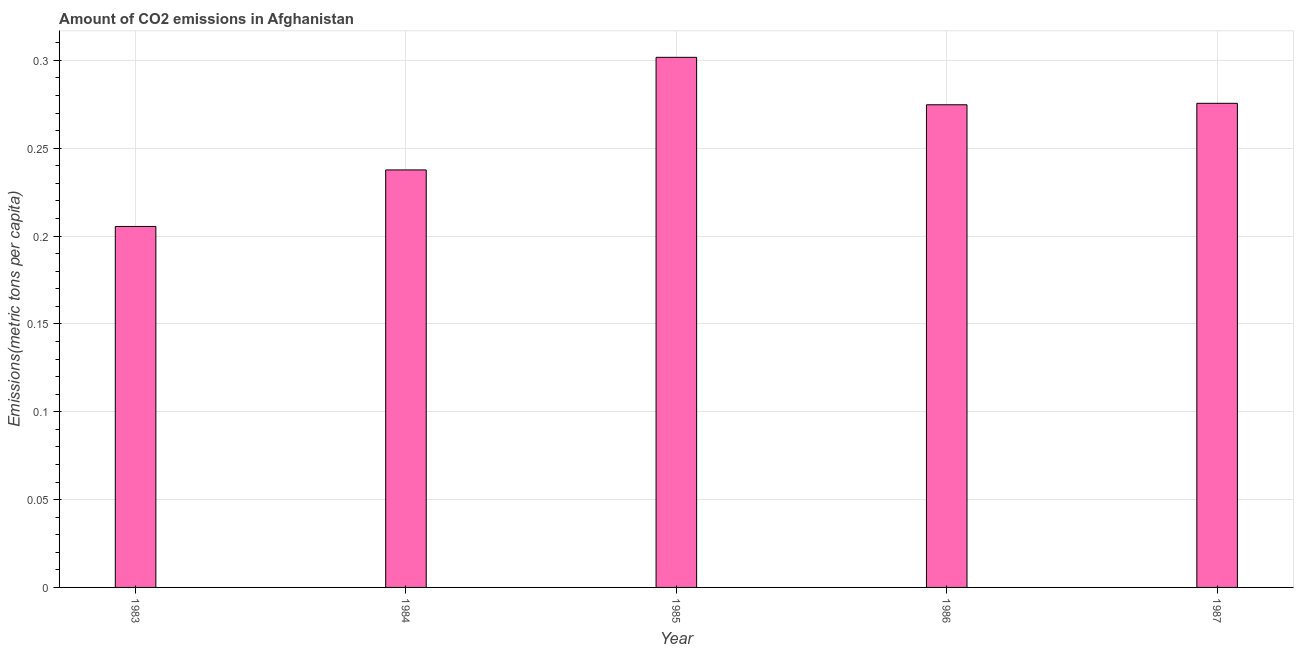Does the graph contain grids?
Give a very brief answer. Yes. What is the title of the graph?
Your answer should be very brief. Amount of CO2 emissions in Afghanistan. What is the label or title of the Y-axis?
Make the answer very short. Emissions(metric tons per capita). What is the amount of co2 emissions in 1986?
Offer a terse response. 0.27. Across all years, what is the maximum amount of co2 emissions?
Provide a succinct answer. 0.3. Across all years, what is the minimum amount of co2 emissions?
Offer a very short reply. 0.21. In which year was the amount of co2 emissions maximum?
Provide a short and direct response. 1985. What is the sum of the amount of co2 emissions?
Offer a terse response. 1.3. What is the difference between the amount of co2 emissions in 1984 and 1986?
Your response must be concise. -0.04. What is the average amount of co2 emissions per year?
Keep it short and to the point. 0.26. What is the median amount of co2 emissions?
Provide a succinct answer. 0.27. In how many years, is the amount of co2 emissions greater than 0.28 metric tons per capita?
Your answer should be very brief. 1. Do a majority of the years between 1986 and 1985 (inclusive) have amount of co2 emissions greater than 0.26 metric tons per capita?
Your answer should be compact. No. What is the ratio of the amount of co2 emissions in 1984 to that in 1986?
Provide a succinct answer. 0.86. What is the difference between the highest and the second highest amount of co2 emissions?
Your response must be concise. 0.03. How many bars are there?
Give a very brief answer. 5. How many years are there in the graph?
Give a very brief answer. 5. What is the Emissions(metric tons per capita) in 1983?
Your answer should be compact. 0.21. What is the Emissions(metric tons per capita) of 1984?
Give a very brief answer. 0.24. What is the Emissions(metric tons per capita) of 1985?
Give a very brief answer. 0.3. What is the Emissions(metric tons per capita) of 1986?
Your answer should be very brief. 0.27. What is the Emissions(metric tons per capita) of 1987?
Give a very brief answer. 0.28. What is the difference between the Emissions(metric tons per capita) in 1983 and 1984?
Your response must be concise. -0.03. What is the difference between the Emissions(metric tons per capita) in 1983 and 1985?
Ensure brevity in your answer.  -0.1. What is the difference between the Emissions(metric tons per capita) in 1983 and 1986?
Your answer should be very brief. -0.07. What is the difference between the Emissions(metric tons per capita) in 1983 and 1987?
Give a very brief answer. -0.07. What is the difference between the Emissions(metric tons per capita) in 1984 and 1985?
Keep it short and to the point. -0.06. What is the difference between the Emissions(metric tons per capita) in 1984 and 1986?
Your response must be concise. -0.04. What is the difference between the Emissions(metric tons per capita) in 1984 and 1987?
Provide a succinct answer. -0.04. What is the difference between the Emissions(metric tons per capita) in 1985 and 1986?
Provide a succinct answer. 0.03. What is the difference between the Emissions(metric tons per capita) in 1985 and 1987?
Provide a short and direct response. 0.03. What is the difference between the Emissions(metric tons per capita) in 1986 and 1987?
Provide a short and direct response. -0. What is the ratio of the Emissions(metric tons per capita) in 1983 to that in 1984?
Offer a very short reply. 0.86. What is the ratio of the Emissions(metric tons per capita) in 1983 to that in 1985?
Offer a very short reply. 0.68. What is the ratio of the Emissions(metric tons per capita) in 1983 to that in 1986?
Offer a very short reply. 0.75. What is the ratio of the Emissions(metric tons per capita) in 1983 to that in 1987?
Your answer should be compact. 0.75. What is the ratio of the Emissions(metric tons per capita) in 1984 to that in 1985?
Offer a terse response. 0.79. What is the ratio of the Emissions(metric tons per capita) in 1984 to that in 1986?
Ensure brevity in your answer.  0.86. What is the ratio of the Emissions(metric tons per capita) in 1984 to that in 1987?
Your response must be concise. 0.86. What is the ratio of the Emissions(metric tons per capita) in 1985 to that in 1986?
Give a very brief answer. 1.1. What is the ratio of the Emissions(metric tons per capita) in 1985 to that in 1987?
Keep it short and to the point. 1.09. What is the ratio of the Emissions(metric tons per capita) in 1986 to that in 1987?
Your response must be concise. 1. 